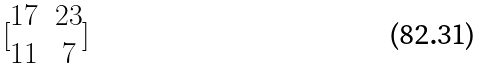Convert formula to latex. <formula><loc_0><loc_0><loc_500><loc_500>[ \begin{matrix} 1 7 & 2 3 \\ 1 1 & 7 \end{matrix} ]</formula> 